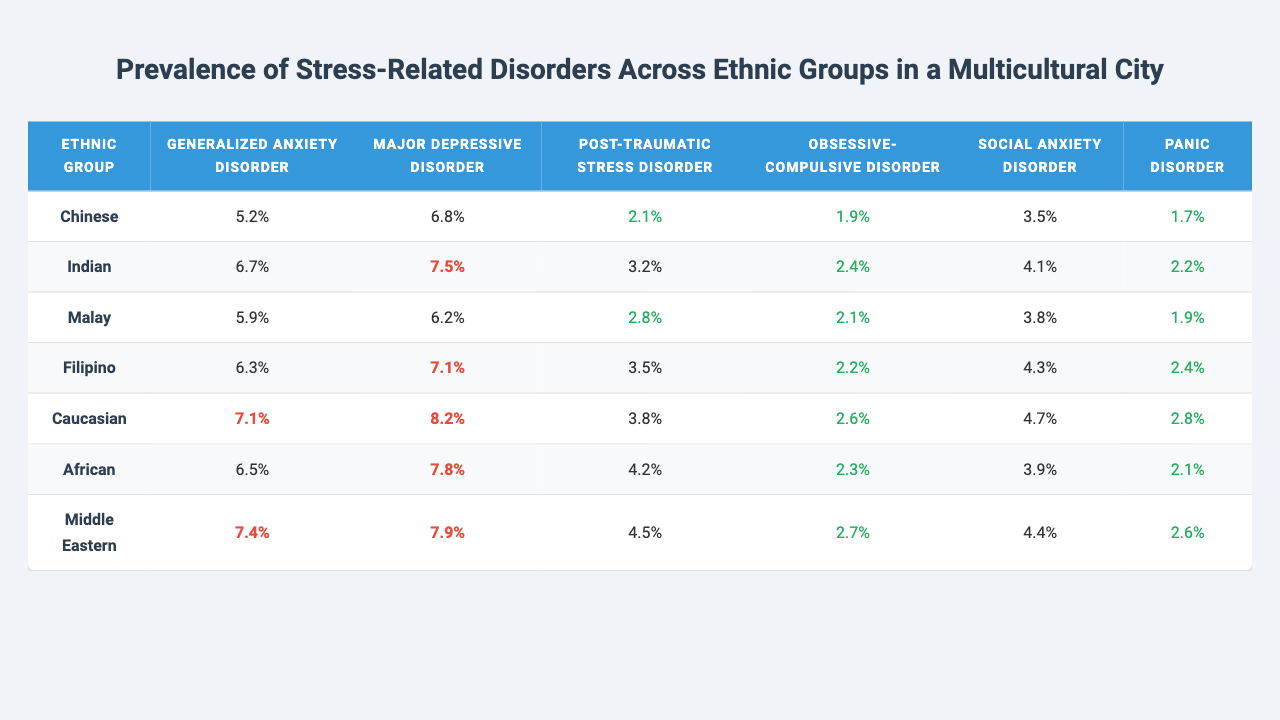What is the prevalence of Major Depressive Disorder in the Filipino ethnic group? The table indicates that the prevalence of Major Depressive Disorder in the Filipino group is shown in the corresponding cell under the Filipino row and Major Depressive Disorder column, which is 7.1%.
Answer: 7.1% Which ethnic group has the highest prevalence of Generalized Anxiety Disorder? By comparing the values for Generalized Anxiety Disorder across all ethnic groups in the table, Caucasian has the highest prevalence at 7.1%.
Answer: Caucasian What is the average prevalence of Panic Disorder across all ethnic groups? To calculate the average, sum the prevalence values for Panic Disorder across all groups: (1.7 + 2.2 + 1.9 + 2.4 + 2.8 + 2.1 + 2.6) = 15.7, then divide by the number of groups (7): 15.7 / 7 = 2.24%.
Answer: 2.24% Is the prevalence of Post-Traumatic Stress Disorder higher in the African group compared to the Indian group? The prevalence of Post-Traumatic Stress Disorder is 4.2% for the African group and 3.2% for the Indian group. Since 4.2% is greater than 3.2%, the prevalence is indeed higher in the African group.
Answer: Yes What are the top three ethnic groups with the highest prevalence of Social Anxiety Disorder? Sort the values in the Social Anxiety Disorder column from highest to lowest: Caucasian (4.7), Filipino (4.3), and Middle Eastern (4.4). This shows that Caucasian, Filipino, and Middle Eastern are the top three groups with the highest prevalence for Social Anxiety Disorder.
Answer: Caucasian, Filipino, Middle Eastern What is the difference in prevalence of Obsessive-Compulsive Disorder between the Chinese and Indian ethnic groups? The prevalence for the Chinese group is 1.9% and for the Indian group is 2.4%. The difference is calculated as 2.4% - 1.9% = 0.5%.
Answer: 0.5% Do any ethnic groups have a prevalence of Generalized Anxiety Disorder below 6%? Checking the Generalized Anxiety Disorder prevalence values in the table, the Chinese (5.2%) and Malay (5.9%) groups fall below 6%.
Answer: Yes Which disorder has the highest average prevalence across all ethnic groups? Calculate the average for each disorder: Generalized Anxiety Disorder (6.4%), Major Depressive Disorder (7.4%), Post-Traumatic Stress Disorder (3.5%), Obsessive-Compulsive Disorder (2.4%), Social Anxiety Disorder (4.0%), and Panic Disorder (2.4%). Major Depressive Disorder has the highest average prevalence at 7.4%.
Answer: Major Depressive Disorder Is the prevalence of Panic Disorder in the Malaysian group equal to that in the Filipino group? The Panic Disorder prevalence for Malaysians is 1.9%, while for Filipinos, it is 2.4%. Since these values are not the same, the statement is false.
Answer: No Which group has the lowest prevalence of Post-Traumatic Stress Disorder? Looking at the table, the Chinese group has the lowest prevalence of Post-Traumatic Stress Disorder at 2.1%.
Answer: Chinese 